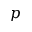Convert formula to latex. <formula><loc_0><loc_0><loc_500><loc_500>p</formula> 